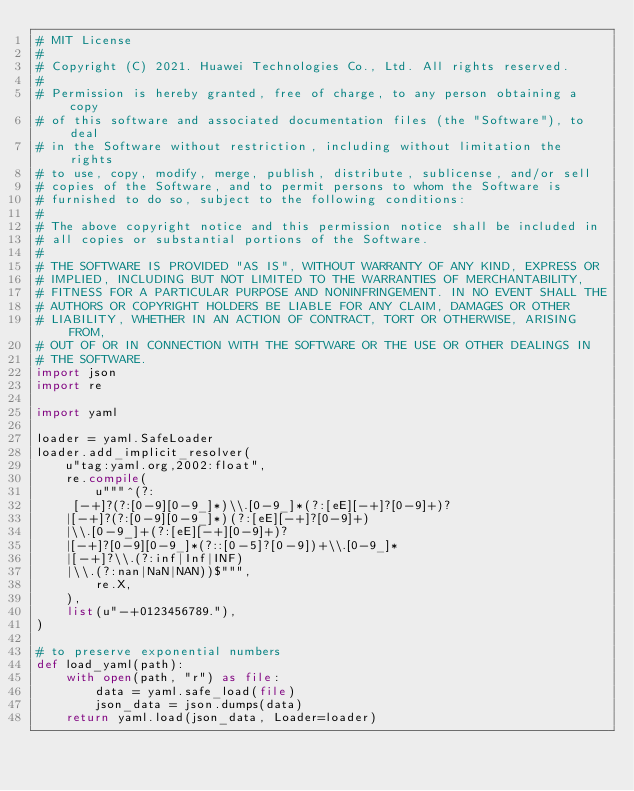Convert code to text. <code><loc_0><loc_0><loc_500><loc_500><_Python_># MIT License
#
# Copyright (C) 2021. Huawei Technologies Co., Ltd. All rights reserved.
#
# Permission is hereby granted, free of charge, to any person obtaining a copy
# of this software and associated documentation files (the "Software"), to deal
# in the Software without restriction, including without limitation the rights
# to use, copy, modify, merge, publish, distribute, sublicense, and/or sell
# copies of the Software, and to permit persons to whom the Software is
# furnished to do so, subject to the following conditions:
#
# The above copyright notice and this permission notice shall be included in
# all copies or substantial portions of the Software.
#
# THE SOFTWARE IS PROVIDED "AS IS", WITHOUT WARRANTY OF ANY KIND, EXPRESS OR
# IMPLIED, INCLUDING BUT NOT LIMITED TO THE WARRANTIES OF MERCHANTABILITY,
# FITNESS FOR A PARTICULAR PURPOSE AND NONINFRINGEMENT. IN NO EVENT SHALL THE
# AUTHORS OR COPYRIGHT HOLDERS BE LIABLE FOR ANY CLAIM, DAMAGES OR OTHER
# LIABILITY, WHETHER IN AN ACTION OF CONTRACT, TORT OR OTHERWISE, ARISING FROM,
# OUT OF OR IN CONNECTION WITH THE SOFTWARE OR THE USE OR OTHER DEALINGS IN
# THE SOFTWARE.
import json
import re

import yaml

loader = yaml.SafeLoader
loader.add_implicit_resolver(
    u"tag:yaml.org,2002:float",
    re.compile(
        u"""^(?:
     [-+]?(?:[0-9][0-9_]*)\\.[0-9_]*(?:[eE][-+]?[0-9]+)?
    |[-+]?(?:[0-9][0-9_]*)(?:[eE][-+]?[0-9]+)
    |\\.[0-9_]+(?:[eE][-+][0-9]+)?
    |[-+]?[0-9][0-9_]*(?::[0-5]?[0-9])+\\.[0-9_]*
    |[-+]?\\.(?:inf|Inf|INF)
    |\\.(?:nan|NaN|NAN))$""",
        re.X,
    ),
    list(u"-+0123456789."),
)

# to preserve exponential numbers
def load_yaml(path):
    with open(path, "r") as file:
        data = yaml.safe_load(file)
        json_data = json.dumps(data)
    return yaml.load(json_data, Loader=loader)
</code> 